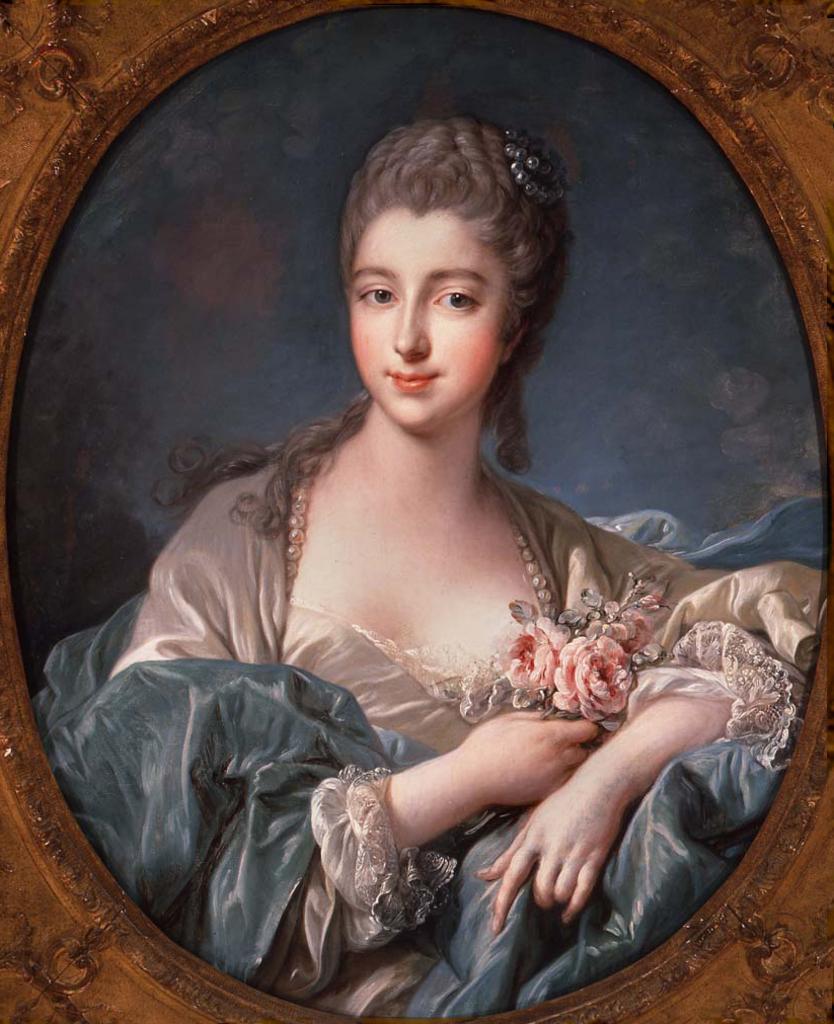Can you describe this image briefly? There is a painting of a woman as we can see in the middle of this image. 